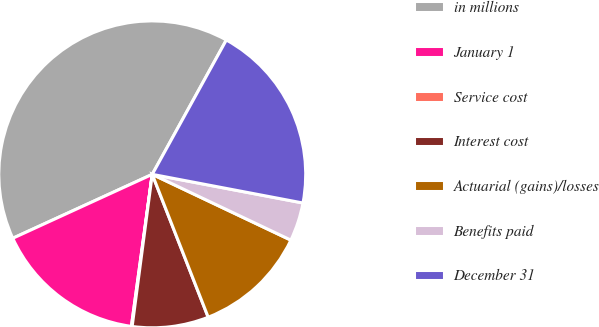Convert chart to OTSL. <chart><loc_0><loc_0><loc_500><loc_500><pie_chart><fcel>in millions<fcel>January 1<fcel>Service cost<fcel>Interest cost<fcel>Actuarial (gains)/losses<fcel>Benefits paid<fcel>December 31<nl><fcel>39.86%<fcel>15.99%<fcel>0.08%<fcel>8.03%<fcel>12.01%<fcel>4.06%<fcel>19.97%<nl></chart> 